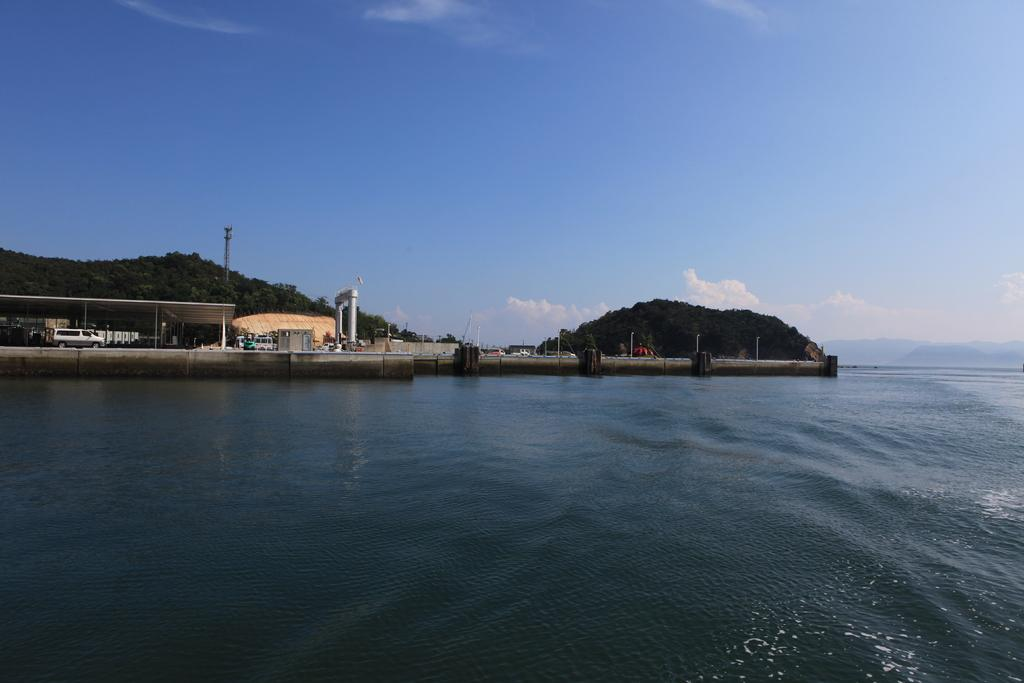What type of structure can be seen in the image? There is a shed in the image. What else is present in the image besides the shed? There are vehicles, electrical poles, mountains, trees, water, a bridge, and the sky visible in the image. Can you describe the vehicles in the image? The provided facts do not specify the type or number of vehicles in the image. What natural features can be seen in the image? Mountains, trees, water, and the sky are natural features visible in the image. What type of silk is being used to make the bridge in the image? There is no silk present in the image; the bridge is likely made of a different material, such as concrete or steel. 